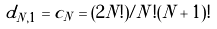Convert formula to latex. <formula><loc_0><loc_0><loc_500><loc_500>d _ { N , 1 } = c _ { N } = ( 2 N ! ) / N ! ( N + 1 ) !</formula> 